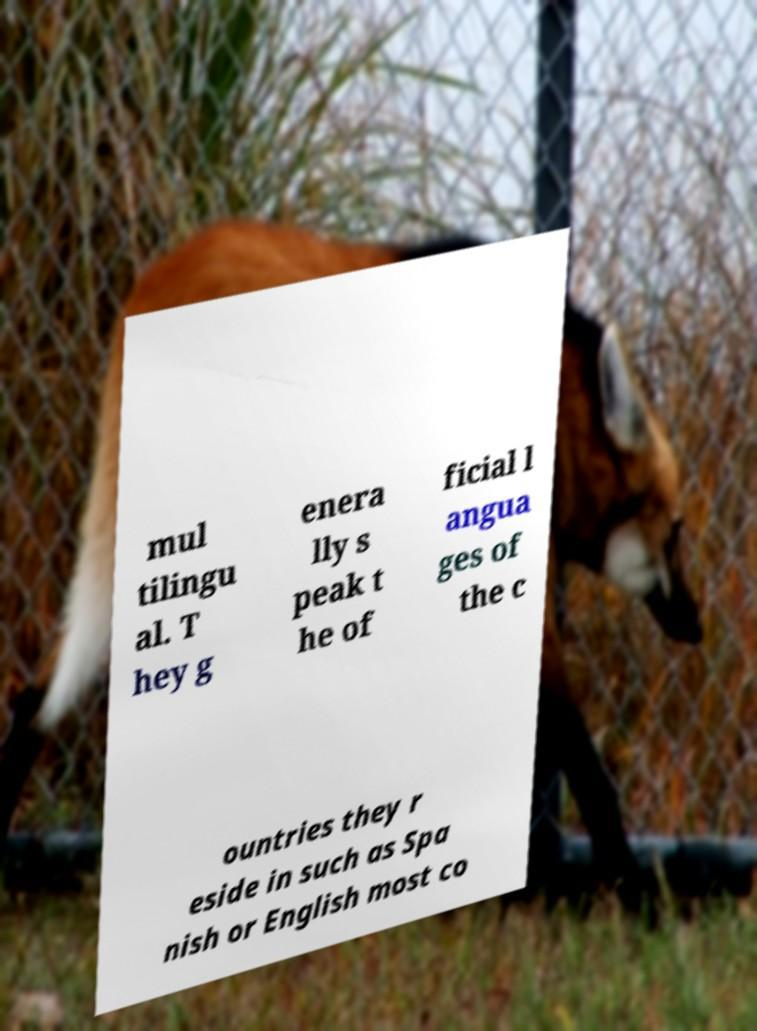Please identify and transcribe the text found in this image. mul tilingu al. T hey g enera lly s peak t he of ficial l angua ges of the c ountries they r eside in such as Spa nish or English most co 